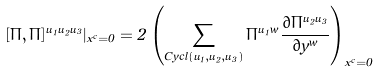Convert formula to latex. <formula><loc_0><loc_0><loc_500><loc_500>[ \Pi , \Pi ] ^ { u _ { 1 } u _ { 2 } u _ { 3 } } | _ { x ^ { c } = 0 } = 2 \left ( \sum _ { C y c l ( u _ { 1 } , u _ { 2 } , u _ { 3 } ) } \Pi ^ { u _ { 1 } w } \frac { \partial \Pi ^ { u _ { 2 } u _ { 3 } } } { \partial y ^ { w } } \right ) _ { x ^ { c } = 0 }</formula> 